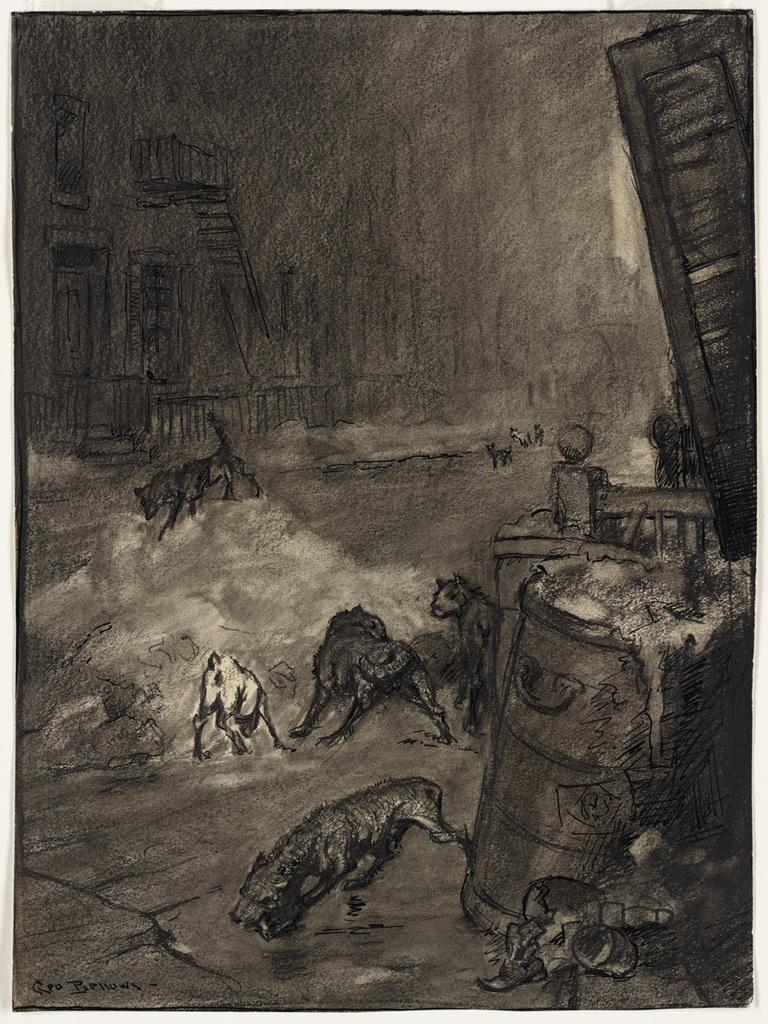What is depicted in the image? There is a sketch of animals in the image. What specific features can be seen in the sketch? There are grills and a wall in the sketch. Are there any living beings in the sketch? Yes, there is a person in the sketch. What other objects are present in the sketch? There are other objects in the sketch, but their specific details are not mentioned in the provided facts. How many eggs are being washed in the basin in the image? There is no basin or eggs present in the image; it features a sketch of animals with grills, a wall, and a person. 